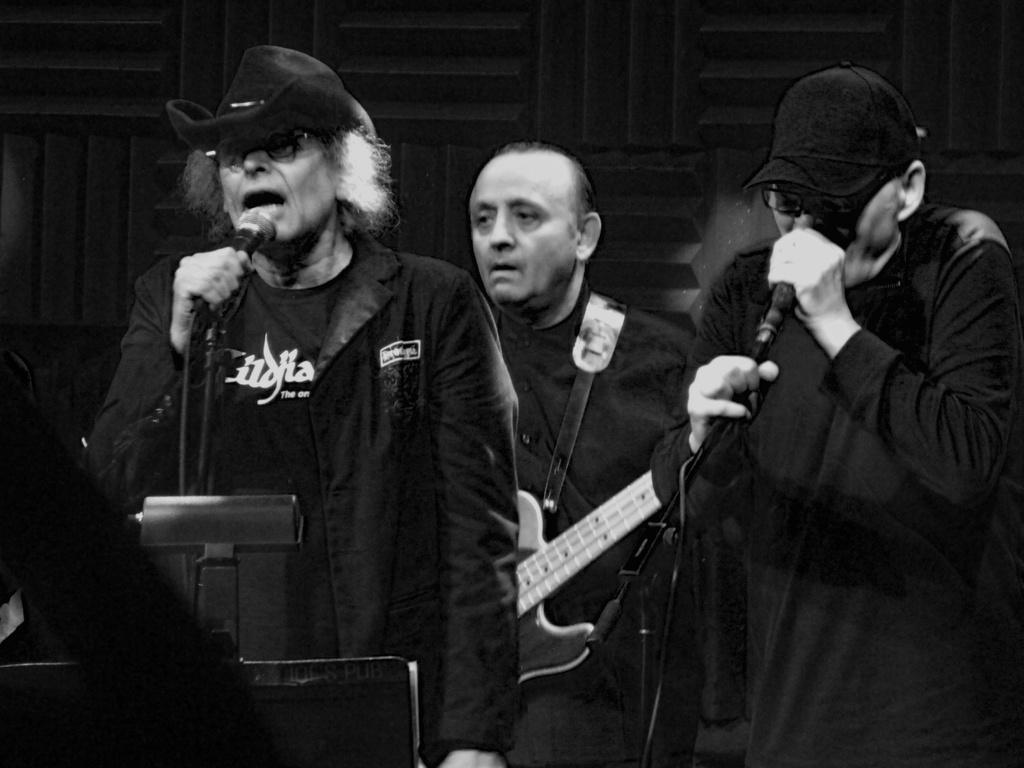In one or two sentences, can you explain what this image depicts? In the image there are three people. On right side there is a man holding a microphone, on left side there is another man holding a microphone and opened his mouth for singing. In background there is another man holding a guitar and playing it. 